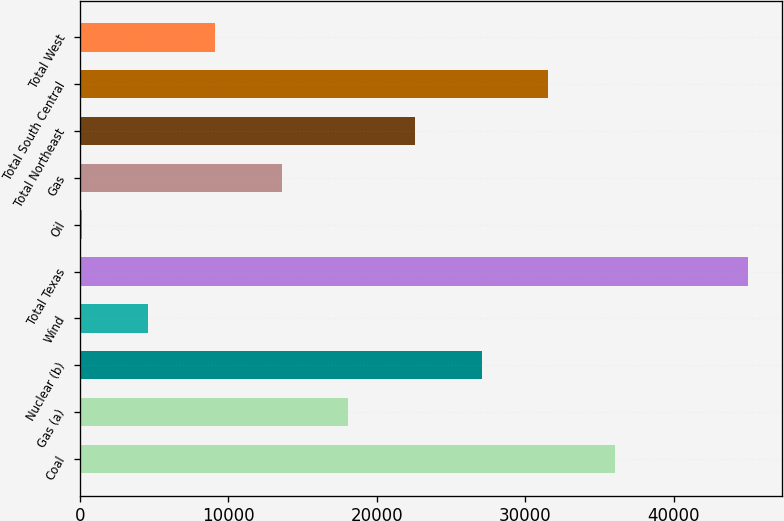Convert chart. <chart><loc_0><loc_0><loc_500><loc_500><bar_chart><fcel>Coal<fcel>Gas (a)<fcel>Nuclear (b)<fcel>Wind<fcel>Total Texas<fcel>Oil<fcel>Gas<fcel>Total Northeast<fcel>Total South Central<fcel>Total West<nl><fcel>36021.2<fcel>18077.6<fcel>27049.4<fcel>4619.9<fcel>44993<fcel>134<fcel>13591.7<fcel>22563.5<fcel>31535.3<fcel>9105.8<nl></chart> 